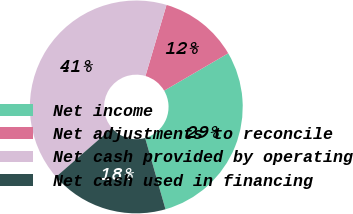Convert chart to OTSL. <chart><loc_0><loc_0><loc_500><loc_500><pie_chart><fcel>Net income<fcel>Net adjustments to reconcile<fcel>Net cash provided by operating<fcel>Net cash used in financing<nl><fcel>28.98%<fcel>12.01%<fcel>40.99%<fcel>18.02%<nl></chart> 